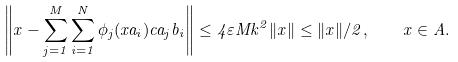Convert formula to latex. <formula><loc_0><loc_0><loc_500><loc_500>\left \| x - \sum ^ { M } _ { j = 1 } \sum ^ { N } _ { i = 1 } \phi _ { j } ( x a _ { i } ) c a _ { j } b _ { i } \right \| \leq 4 \varepsilon M k ^ { 2 } \| x \| \leq \| x \| / 2 , \quad x \in A .</formula> 